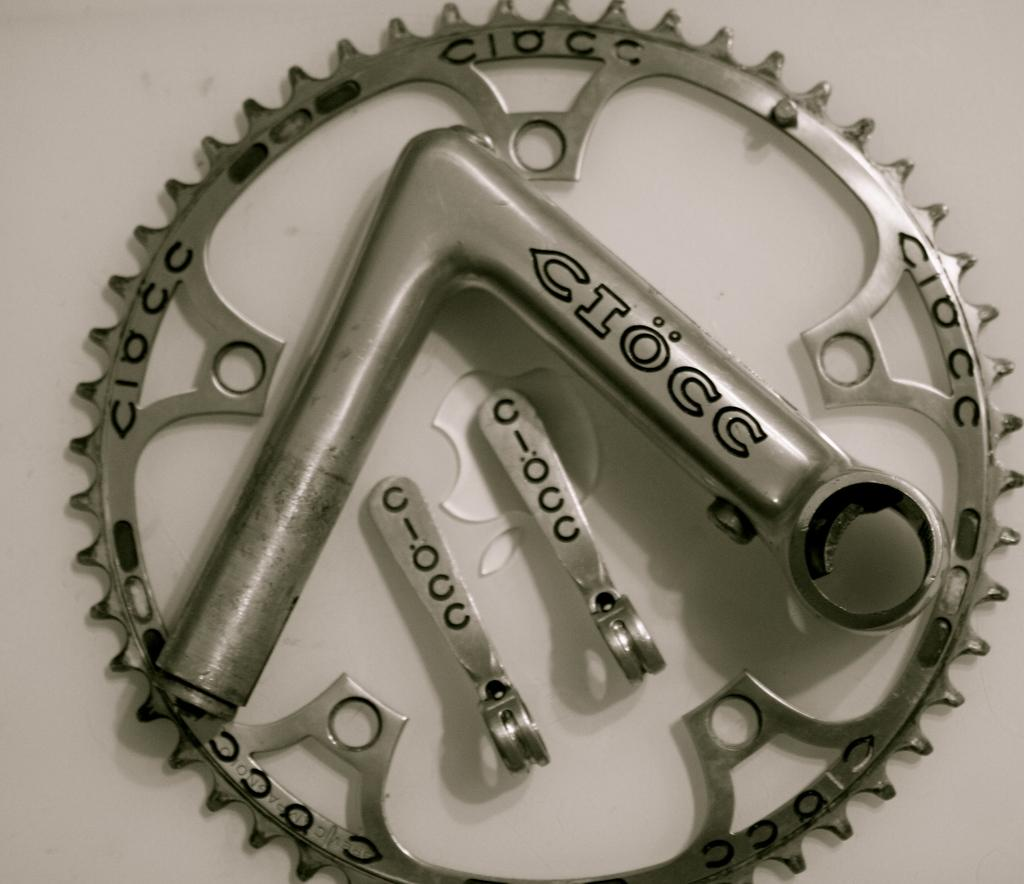What is the color of the metal object in the image? The metal object in the image is silver-colored. What is the metal object placed on in the image? The metal object is on a white surface. What direction is the beginner facing in the image? There is no person or direction mentioned in the image; it only features a silver-colored metal object on a white surface. 